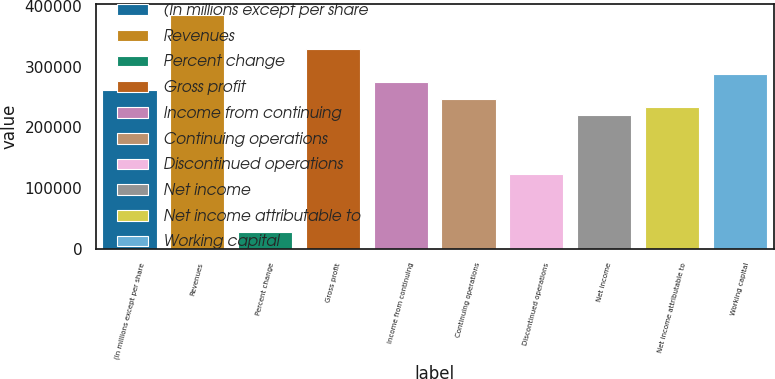<chart> <loc_0><loc_0><loc_500><loc_500><bar_chart><fcel>(In millions except per share<fcel>Revenues<fcel>Percent change<fcel>Gross profit<fcel>Income from continuing<fcel>Continuing operations<fcel>Discontinued operations<fcel>Net income<fcel>Net income attributable to<fcel>Working capital<nl><fcel>261044<fcel>384696<fcel>27479.1<fcel>329740<fcel>274783<fcel>247305<fcel>123653<fcel>219827<fcel>233566<fcel>288522<nl></chart> 